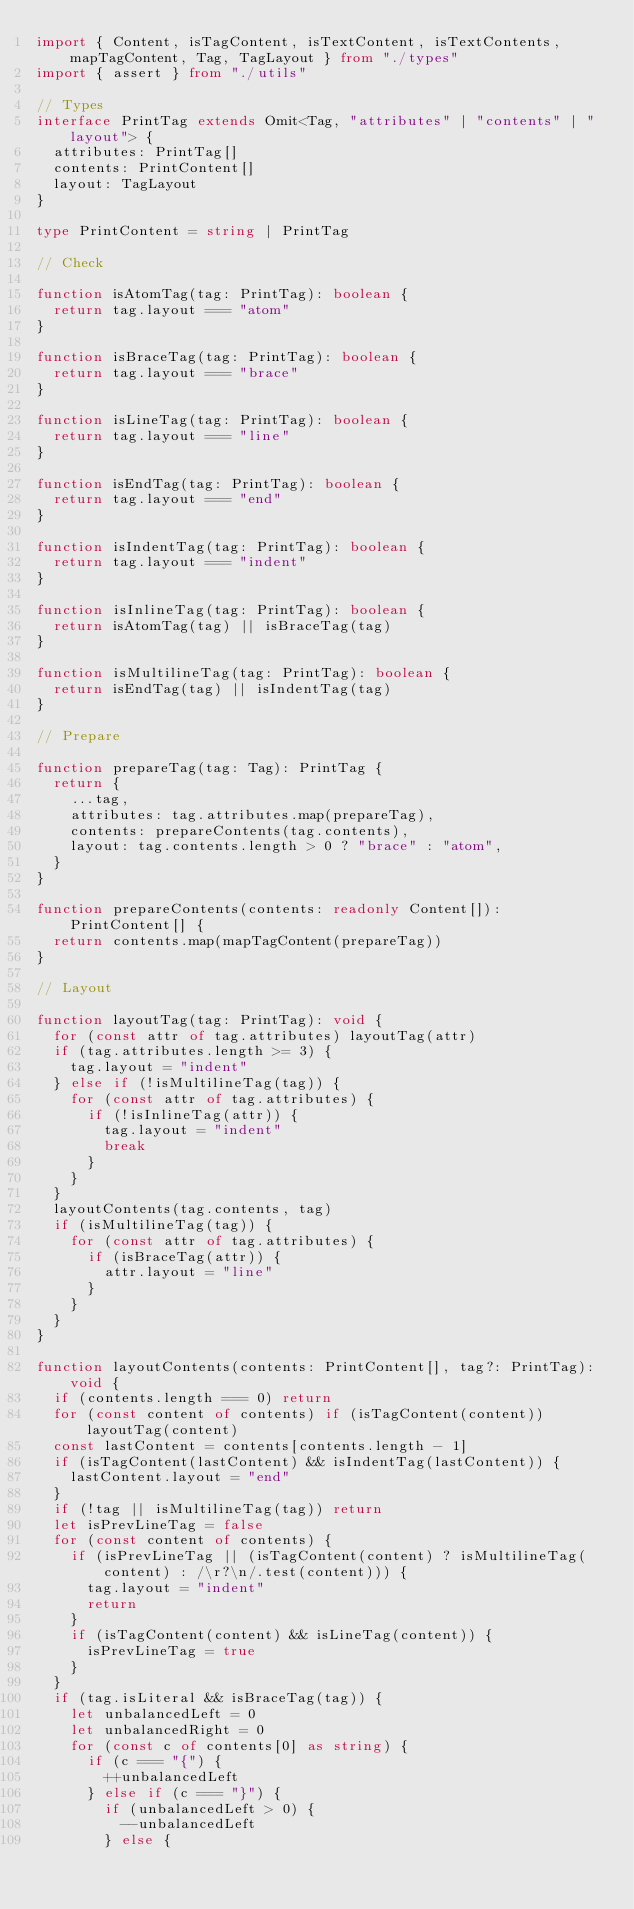<code> <loc_0><loc_0><loc_500><loc_500><_TypeScript_>import { Content, isTagContent, isTextContent, isTextContents, mapTagContent, Tag, TagLayout } from "./types"
import { assert } from "./utils"

// Types
interface PrintTag extends Omit<Tag, "attributes" | "contents" | "layout"> {
  attributes: PrintTag[]
  contents: PrintContent[]
  layout: TagLayout
}

type PrintContent = string | PrintTag

// Check

function isAtomTag(tag: PrintTag): boolean {
  return tag.layout === "atom"
}

function isBraceTag(tag: PrintTag): boolean {
  return tag.layout === "brace"
}

function isLineTag(tag: PrintTag): boolean {
  return tag.layout === "line"
}

function isEndTag(tag: PrintTag): boolean {
  return tag.layout === "end"
}

function isIndentTag(tag: PrintTag): boolean {
  return tag.layout === "indent"
}

function isInlineTag(tag: PrintTag): boolean {
  return isAtomTag(tag) || isBraceTag(tag)
}

function isMultilineTag(tag: PrintTag): boolean {
  return isEndTag(tag) || isIndentTag(tag)
}

// Prepare

function prepareTag(tag: Tag): PrintTag {
  return {
    ...tag,
    attributes: tag.attributes.map(prepareTag),
    contents: prepareContents(tag.contents),
    layout: tag.contents.length > 0 ? "brace" : "atom",
  }
}

function prepareContents(contents: readonly Content[]): PrintContent[] {
  return contents.map(mapTagContent(prepareTag))
}

// Layout

function layoutTag(tag: PrintTag): void {
  for (const attr of tag.attributes) layoutTag(attr)
  if (tag.attributes.length >= 3) {
    tag.layout = "indent"
  } else if (!isMultilineTag(tag)) {
    for (const attr of tag.attributes) {
      if (!isInlineTag(attr)) {
        tag.layout = "indent"
        break
      }
    }
  }
  layoutContents(tag.contents, tag)
  if (isMultilineTag(tag)) {
    for (const attr of tag.attributes) {
      if (isBraceTag(attr)) {
        attr.layout = "line"
      }
    }
  }
}

function layoutContents(contents: PrintContent[], tag?: PrintTag): void {
  if (contents.length === 0) return
  for (const content of contents) if (isTagContent(content)) layoutTag(content)
  const lastContent = contents[contents.length - 1]
  if (isTagContent(lastContent) && isIndentTag(lastContent)) {
    lastContent.layout = "end"
  }
  if (!tag || isMultilineTag(tag)) return
  let isPrevLineTag = false
  for (const content of contents) {
    if (isPrevLineTag || (isTagContent(content) ? isMultilineTag(content) : /\r?\n/.test(content))) {
      tag.layout = "indent"
      return
    }
    if (isTagContent(content) && isLineTag(content)) {
      isPrevLineTag = true
    }
  }
  if (tag.isLiteral && isBraceTag(tag)) {
    let unbalancedLeft = 0
    let unbalancedRight = 0
    for (const c of contents[0] as string) {
      if (c === "{") {
        ++unbalancedLeft
      } else if (c === "}") {
        if (unbalancedLeft > 0) {
          --unbalancedLeft
        } else {</code> 